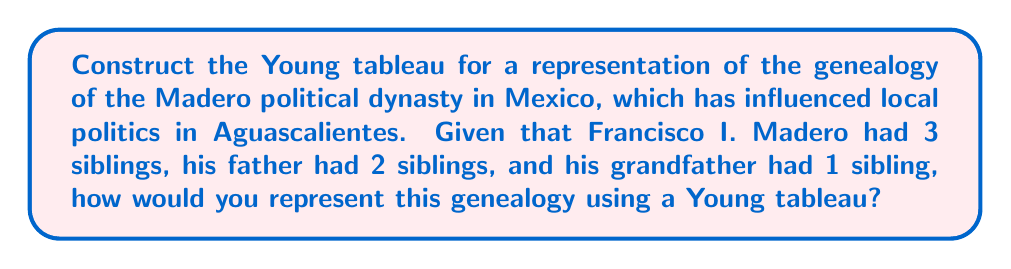What is the answer to this math problem? To construct a Young tableau for the Madero political dynasty's genealogy, we'll follow these steps:

1. Identify the generations: We have 3 generations (grandfather, father, and Francisco I. Madero's generation).

2. Count family members in each generation:
   - Grandfather's generation: 2 (grandfather + 1 sibling)
   - Father's generation: 3 (father + 2 siblings)
   - Francisco I. Madero's generation: 4 (Francisco + 3 siblings)

3. Construct the Young tableau:
   - Each row represents a generation
   - The number of boxes in each row corresponds to the number of family members in that generation
   - We arrange the rows in descending order of length

The resulting Young tableau will look like this:

$$\begin{array}{|c|c|c|c|}
\hline
\square & \square & \square & \square \\
\hline
\square & \square & \square \\
\cline{1-3}
\square & \square \\
\cline{1-2}
\end{array}$$

This Young tableau represents the Madero dynasty's genealogy over three generations, with each row corresponding to a generation and the number of boxes in each row representing the number of family members in that generation.
Answer: $$\begin{array}{|c|c|c|c|}
\hline
\square & \square & \square & \square \\
\hline
\square & \square & \square \\
\cline{1-3}
\square & \square \\
\cline{1-2}
\end{array}$$ 